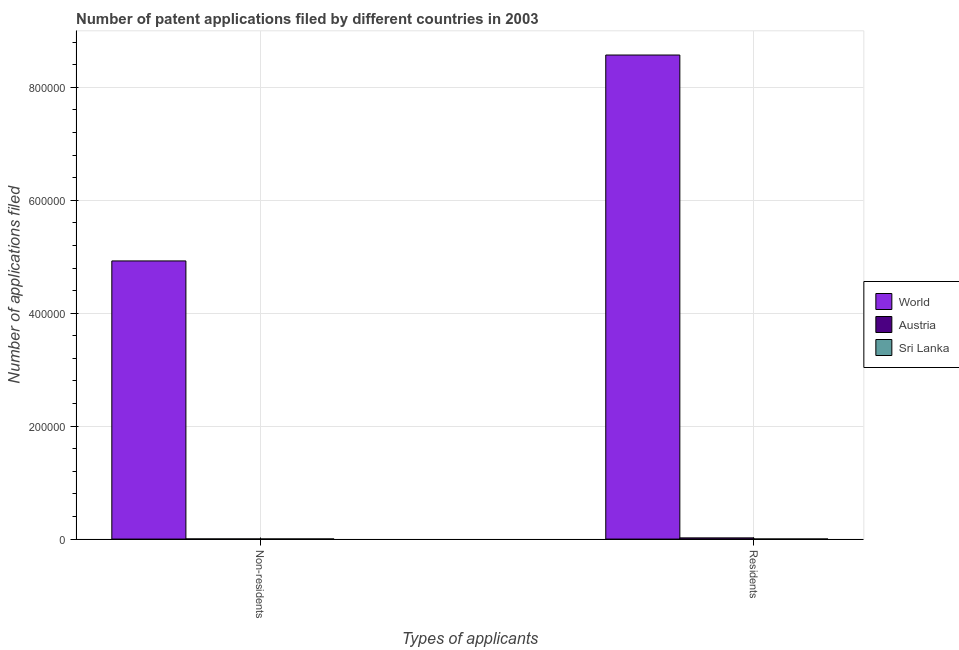Are the number of bars per tick equal to the number of legend labels?
Offer a very short reply. Yes. How many bars are there on the 2nd tick from the left?
Make the answer very short. 3. How many bars are there on the 1st tick from the right?
Your response must be concise. 3. What is the label of the 2nd group of bars from the left?
Your response must be concise. Residents. What is the number of patent applications by non residents in Austria?
Provide a succinct answer. 213. Across all countries, what is the maximum number of patent applications by non residents?
Make the answer very short. 4.93e+05. Across all countries, what is the minimum number of patent applications by non residents?
Offer a very short reply. 189. In which country was the number of patent applications by non residents minimum?
Offer a very short reply. Sri Lanka. What is the total number of patent applications by non residents in the graph?
Provide a short and direct response. 4.93e+05. What is the difference between the number of patent applications by residents in Sri Lanka and that in World?
Offer a very short reply. -8.57e+05. What is the difference between the number of patent applications by non residents in World and the number of patent applications by residents in Austria?
Your answer should be compact. 4.90e+05. What is the average number of patent applications by residents per country?
Give a very brief answer. 2.86e+05. What is the difference between the number of patent applications by non residents and number of patent applications by residents in World?
Your answer should be compact. -3.65e+05. What is the ratio of the number of patent applications by non residents in Sri Lanka to that in Austria?
Your response must be concise. 0.89. What does the 3rd bar from the left in Residents represents?
Provide a succinct answer. Sri Lanka. What does the 1st bar from the right in Residents represents?
Make the answer very short. Sri Lanka. How many countries are there in the graph?
Your response must be concise. 3. What is the difference between two consecutive major ticks on the Y-axis?
Provide a short and direct response. 2.00e+05. Does the graph contain any zero values?
Your response must be concise. No. Where does the legend appear in the graph?
Provide a succinct answer. Center right. How many legend labels are there?
Make the answer very short. 3. What is the title of the graph?
Give a very brief answer. Number of patent applications filed by different countries in 2003. What is the label or title of the X-axis?
Offer a very short reply. Types of applicants. What is the label or title of the Y-axis?
Offer a very short reply. Number of applications filed. What is the Number of applications filed in World in Non-residents?
Keep it short and to the point. 4.93e+05. What is the Number of applications filed of Austria in Non-residents?
Ensure brevity in your answer.  213. What is the Number of applications filed in Sri Lanka in Non-residents?
Provide a succinct answer. 189. What is the Number of applications filed of World in Residents?
Your response must be concise. 8.57e+05. What is the Number of applications filed in Austria in Residents?
Your answer should be very brief. 2120. Across all Types of applicants, what is the maximum Number of applications filed in World?
Your answer should be very brief. 8.57e+05. Across all Types of applicants, what is the maximum Number of applications filed of Austria?
Provide a succinct answer. 2120. Across all Types of applicants, what is the maximum Number of applications filed of Sri Lanka?
Offer a terse response. 189. Across all Types of applicants, what is the minimum Number of applications filed of World?
Provide a succinct answer. 4.93e+05. Across all Types of applicants, what is the minimum Number of applications filed in Austria?
Offer a very short reply. 213. What is the total Number of applications filed of World in the graph?
Your answer should be compact. 1.35e+06. What is the total Number of applications filed in Austria in the graph?
Give a very brief answer. 2333. What is the total Number of applications filed in Sri Lanka in the graph?
Provide a short and direct response. 284. What is the difference between the Number of applications filed in World in Non-residents and that in Residents?
Offer a terse response. -3.65e+05. What is the difference between the Number of applications filed of Austria in Non-residents and that in Residents?
Provide a short and direct response. -1907. What is the difference between the Number of applications filed in Sri Lanka in Non-residents and that in Residents?
Ensure brevity in your answer.  94. What is the difference between the Number of applications filed of World in Non-residents and the Number of applications filed of Austria in Residents?
Keep it short and to the point. 4.90e+05. What is the difference between the Number of applications filed of World in Non-residents and the Number of applications filed of Sri Lanka in Residents?
Provide a short and direct response. 4.92e+05. What is the difference between the Number of applications filed of Austria in Non-residents and the Number of applications filed of Sri Lanka in Residents?
Make the answer very short. 118. What is the average Number of applications filed in World per Types of applicants?
Provide a short and direct response. 6.75e+05. What is the average Number of applications filed in Austria per Types of applicants?
Provide a succinct answer. 1166.5. What is the average Number of applications filed of Sri Lanka per Types of applicants?
Offer a terse response. 142. What is the difference between the Number of applications filed of World and Number of applications filed of Austria in Non-residents?
Your response must be concise. 4.92e+05. What is the difference between the Number of applications filed in World and Number of applications filed in Sri Lanka in Non-residents?
Your answer should be very brief. 4.92e+05. What is the difference between the Number of applications filed of World and Number of applications filed of Austria in Residents?
Provide a succinct answer. 8.55e+05. What is the difference between the Number of applications filed in World and Number of applications filed in Sri Lanka in Residents?
Your answer should be compact. 8.57e+05. What is the difference between the Number of applications filed of Austria and Number of applications filed of Sri Lanka in Residents?
Make the answer very short. 2025. What is the ratio of the Number of applications filed of World in Non-residents to that in Residents?
Your answer should be very brief. 0.57. What is the ratio of the Number of applications filed of Austria in Non-residents to that in Residents?
Offer a terse response. 0.1. What is the ratio of the Number of applications filed of Sri Lanka in Non-residents to that in Residents?
Your answer should be compact. 1.99. What is the difference between the highest and the second highest Number of applications filed of World?
Ensure brevity in your answer.  3.65e+05. What is the difference between the highest and the second highest Number of applications filed in Austria?
Give a very brief answer. 1907. What is the difference between the highest and the second highest Number of applications filed in Sri Lanka?
Your response must be concise. 94. What is the difference between the highest and the lowest Number of applications filed in World?
Give a very brief answer. 3.65e+05. What is the difference between the highest and the lowest Number of applications filed in Austria?
Offer a very short reply. 1907. What is the difference between the highest and the lowest Number of applications filed in Sri Lanka?
Offer a very short reply. 94. 